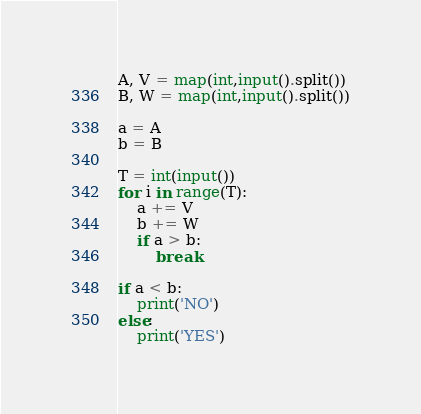Convert code to text. <code><loc_0><loc_0><loc_500><loc_500><_Python_>

A, V = map(int,input().split())
B, W = map(int,input().split())

a = A
b = B

T = int(input())
for i in range(T):
    a += V
    b += W
    if a > b:
        break

if a < b:
    print('NO')
else:
    print('YES')
</code> 